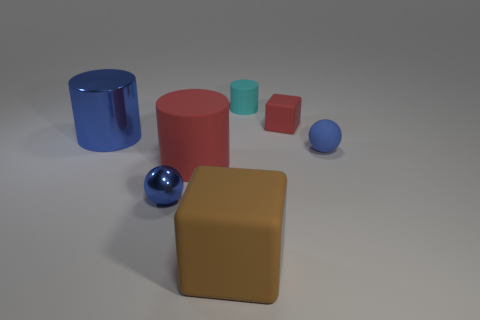What number of objects are tiny objects on the right side of the tiny cube or large metal cylinders? On the right side of the tiny cube, which is the smaller of the two cubes, there is only one tiny object—a small cylindrical piece. In the vicinity of the larger, blue metallic cylinder, there are no tiny objects. Overall, the total count of tiny objects near the specified subjects is one. 